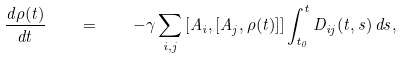<formula> <loc_0><loc_0><loc_500><loc_500>\frac { d \rho ( t ) } { d t } \quad = \quad - \gamma \sum _ { i , j } \left [ A _ { i } , \left [ A _ { j } , \rho ( t ) \right ] \right ] \int _ { t _ { 0 } } ^ { t } D _ { i j } ( t , s ) \, d s ,</formula> 